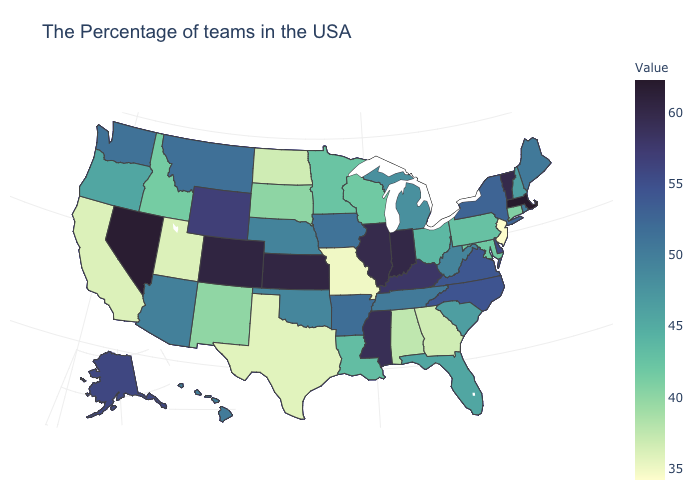Does Mississippi have a higher value than Massachusetts?
Write a very short answer. No. Is the legend a continuous bar?
Answer briefly. Yes. Does Kansas have the lowest value in the USA?
Give a very brief answer. No. Does New Jersey have the lowest value in the USA?
Keep it brief. Yes. Does the map have missing data?
Give a very brief answer. No. Which states hav the highest value in the MidWest?
Write a very short answer. Kansas. Is the legend a continuous bar?
Give a very brief answer. Yes. Which states have the lowest value in the West?
Be succinct. Utah, California. Does Maryland have the lowest value in the USA?
Be succinct. No. 